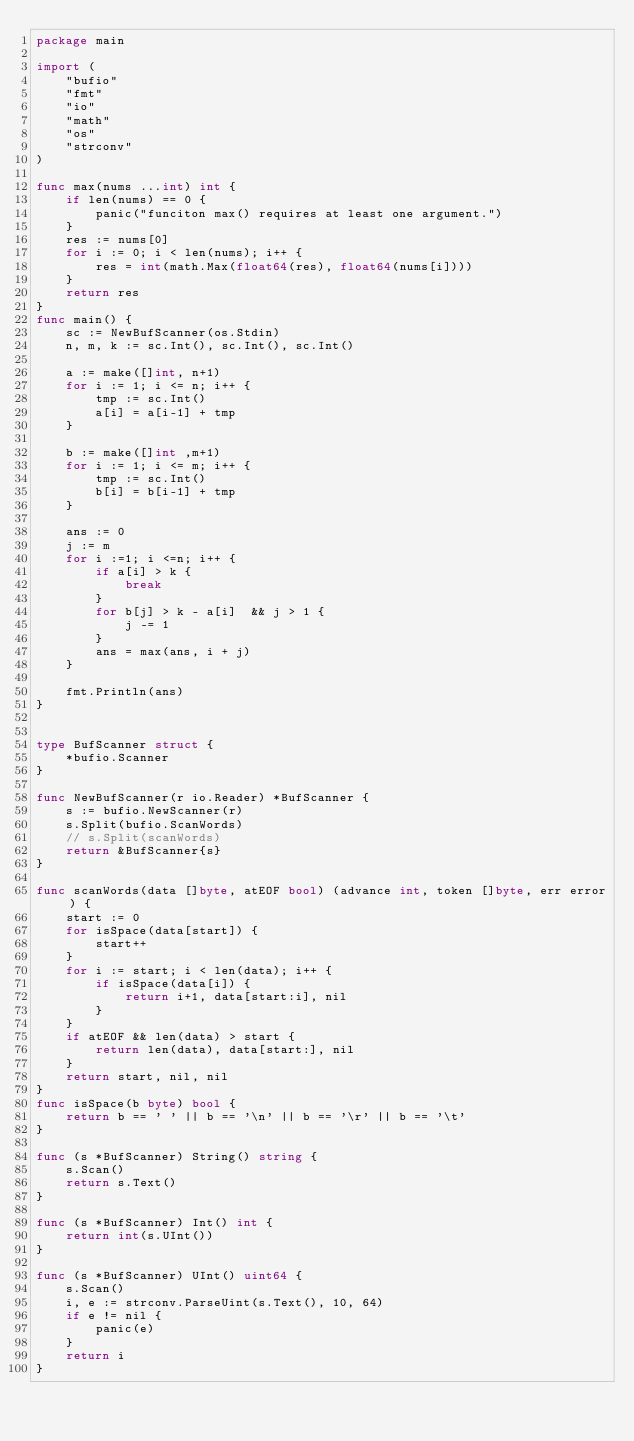Convert code to text. <code><loc_0><loc_0><loc_500><loc_500><_Go_>package main

import (
	"bufio"
	"fmt"
	"io"
	"math"
	"os"
	"strconv"
)

func max(nums ...int) int {
	if len(nums) == 0 {
		panic("funciton max() requires at least one argument.")
	}
	res := nums[0]
	for i := 0; i < len(nums); i++ {
		res = int(math.Max(float64(res), float64(nums[i])))
	}
	return res
}
func main() {
	sc := NewBufScanner(os.Stdin)
	n, m, k := sc.Int(), sc.Int(), sc.Int()

	a := make([]int, n+1)
	for i := 1; i <= n; i++ {
		tmp := sc.Int()
		a[i] = a[i-1] + tmp
	}

	b := make([]int ,m+1)
	for i := 1; i <= m; i++ {
		tmp := sc.Int()
		b[i] = b[i-1] + tmp
	}

	ans := 0
	j := m
	for i :=1; i <=n; i++ {
		if a[i] > k {
			break
		}
		for b[j] > k - a[i]  && j > 1 {
			j -= 1
		}
		ans = max(ans, i + j)
	}

	fmt.Println(ans)
}


type BufScanner struct {
	*bufio.Scanner
}

func NewBufScanner(r io.Reader) *BufScanner {
	s := bufio.NewScanner(r)
	s.Split(bufio.ScanWords)
	// s.Split(scanWords)
	return &BufScanner{s}
}

func scanWords(data []byte, atEOF bool) (advance int, token []byte, err error) {
	start := 0
	for isSpace(data[start]) {
		start++
	}
	for i := start; i < len(data); i++ {
		if isSpace(data[i]) {
			return i+1, data[start:i], nil
		}
	}
	if atEOF && len(data) > start {
		return len(data), data[start:], nil
	}
	return start, nil, nil
}
func isSpace(b byte) bool {
	return b == ' ' || b == '\n' || b == '\r' || b == '\t'
}

func (s *BufScanner) String() string {
	s.Scan()
	return s.Text()
}

func (s *BufScanner) Int() int {
	return int(s.UInt())
}

func (s *BufScanner) UInt() uint64 {
	s.Scan()
	i, e := strconv.ParseUint(s.Text(), 10, 64)
	if e != nil {
		panic(e)
	}
	return i
}
</code> 